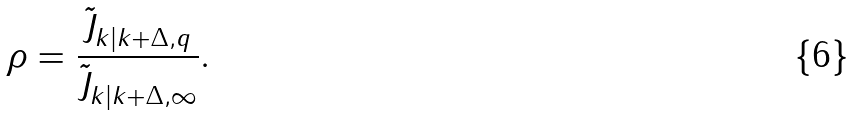<formula> <loc_0><loc_0><loc_500><loc_500>\rho = \frac { \tilde { J } _ { k | k + \Delta , q } } { \tilde { J } _ { k | k + \Delta , \infty } } .</formula> 